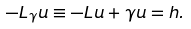<formula> <loc_0><loc_0><loc_500><loc_500>- L _ { \gamma } u \equiv - L u + \gamma u = h .</formula> 